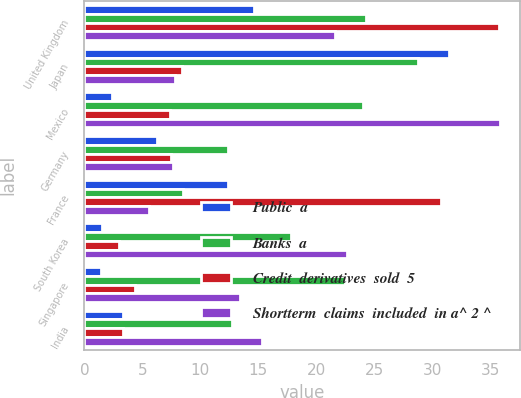<chart> <loc_0><loc_0><loc_500><loc_500><stacked_bar_chart><ecel><fcel>United Kingdom<fcel>Japan<fcel>Mexico<fcel>Germany<fcel>France<fcel>South Korea<fcel>Singapore<fcel>India<nl><fcel>Public  a<fcel>14.6<fcel>31.4<fcel>2.4<fcel>6.3<fcel>12.4<fcel>1.5<fcel>1.4<fcel>3.3<nl><fcel>Banks  a<fcel>24.3<fcel>28.8<fcel>24<fcel>12.4<fcel>8.5<fcel>17.8<fcel>22.5<fcel>12.7<nl><fcel>Credit  derivatives  sold  5<fcel>35.7<fcel>8.4<fcel>7.4<fcel>7.5<fcel>30.7<fcel>3<fcel>4.4<fcel>3.3<nl><fcel>Shortterm  claims  included  in a^ 2 ^<fcel>21.6<fcel>7.8<fcel>35.8<fcel>7.6<fcel>5.6<fcel>22.6<fcel>13.4<fcel>15.3<nl></chart> 